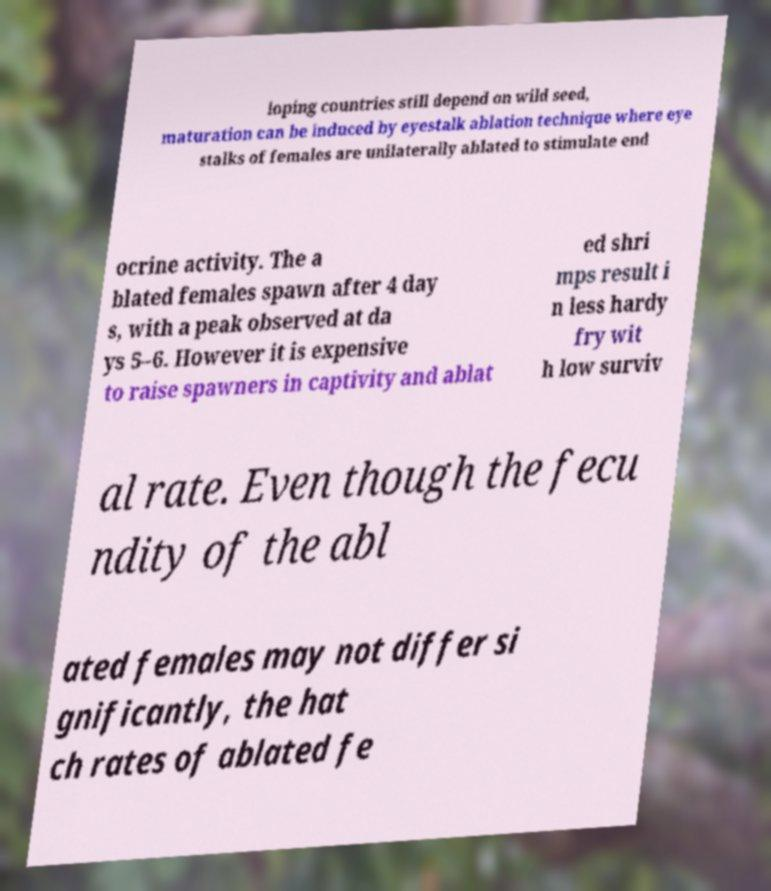Can you read and provide the text displayed in the image?This photo seems to have some interesting text. Can you extract and type it out for me? loping countries still depend on wild seed, maturation can be induced by eyestalk ablation technique where eye stalks of females are unilaterally ablated to stimulate end ocrine activity. The a blated females spawn after 4 day s, with a peak observed at da ys 5–6. However it is expensive to raise spawners in captivity and ablat ed shri mps result i n less hardy fry wit h low surviv al rate. Even though the fecu ndity of the abl ated females may not differ si gnificantly, the hat ch rates of ablated fe 